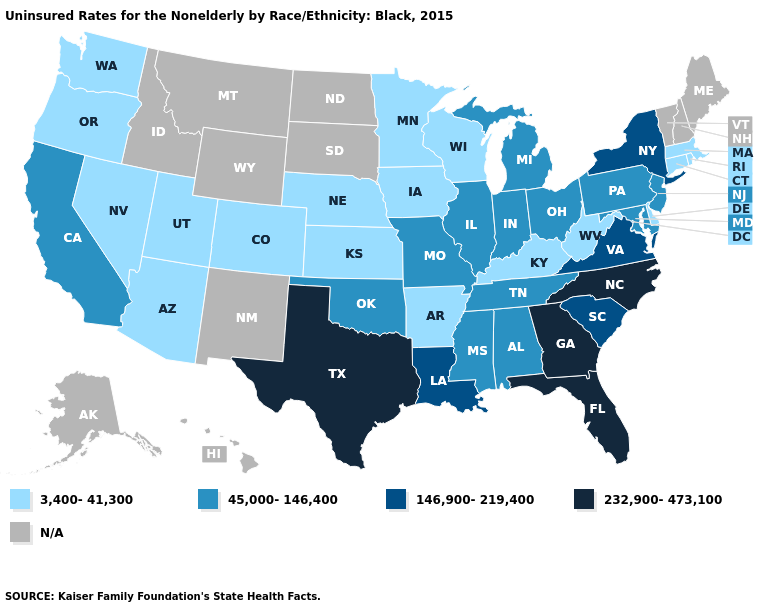Name the states that have a value in the range 45,000-146,400?
Give a very brief answer. Alabama, California, Illinois, Indiana, Maryland, Michigan, Mississippi, Missouri, New Jersey, Ohio, Oklahoma, Pennsylvania, Tennessee. How many symbols are there in the legend?
Short answer required. 5. Does the map have missing data?
Quick response, please. Yes. Name the states that have a value in the range 146,900-219,400?
Concise answer only. Louisiana, New York, South Carolina, Virginia. What is the value of Louisiana?
Keep it brief. 146,900-219,400. What is the value of Alaska?
Give a very brief answer. N/A. What is the value of Alabama?
Keep it brief. 45,000-146,400. Name the states that have a value in the range 45,000-146,400?
Concise answer only. Alabama, California, Illinois, Indiana, Maryland, Michigan, Mississippi, Missouri, New Jersey, Ohio, Oklahoma, Pennsylvania, Tennessee. Which states have the lowest value in the Northeast?
Write a very short answer. Connecticut, Massachusetts, Rhode Island. What is the value of Delaware?
Concise answer only. 3,400-41,300. Which states have the lowest value in the Northeast?
Give a very brief answer. Connecticut, Massachusetts, Rhode Island. Does Maryland have the lowest value in the USA?
Be succinct. No. 